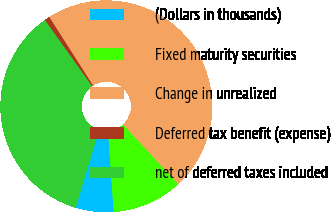Convert chart to OTSL. <chart><loc_0><loc_0><loc_500><loc_500><pie_chart><fcel>(Dollars in thousands)<fcel>Fixed maturity securities<fcel>Change in unrealized<fcel>Deferred tax benefit (expense)<fcel>net of deferred taxes included<nl><fcel>5.78%<fcel>10.78%<fcel>47.17%<fcel>0.79%<fcel>35.48%<nl></chart> 